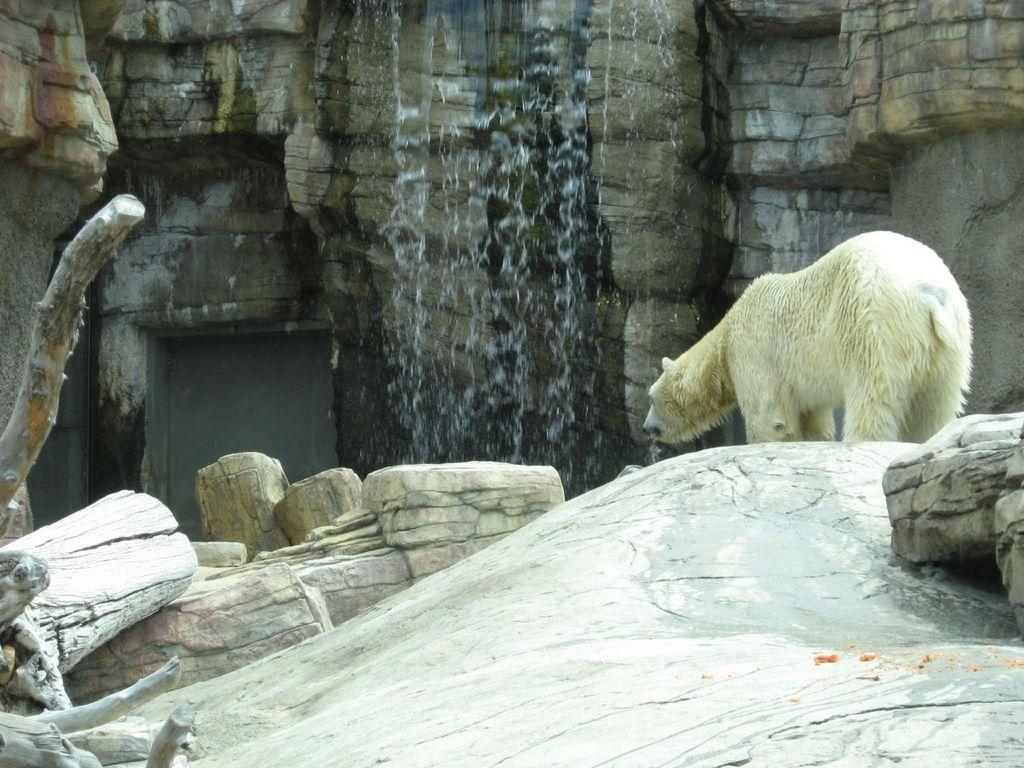What animal can be seen on the right side of the image? There is a polar bear on the right side of the image. What material is present on the left side of the image? There is wood on the left side of the image. What natural feature can be seen in the background of the image? There is a waterfall in the background of the image. What type of landform is visible in the background of the image? There is a hill in the background of the image. What suggestion does the polar bear make to the wood in the image? There is no interaction or suggestion between the polar bear and the wood in the image; they are separate elements. What is the cause of the waterfall in the image? The cause of the waterfall is not visible or described in the image; it could be due to natural geological features or other factors. 